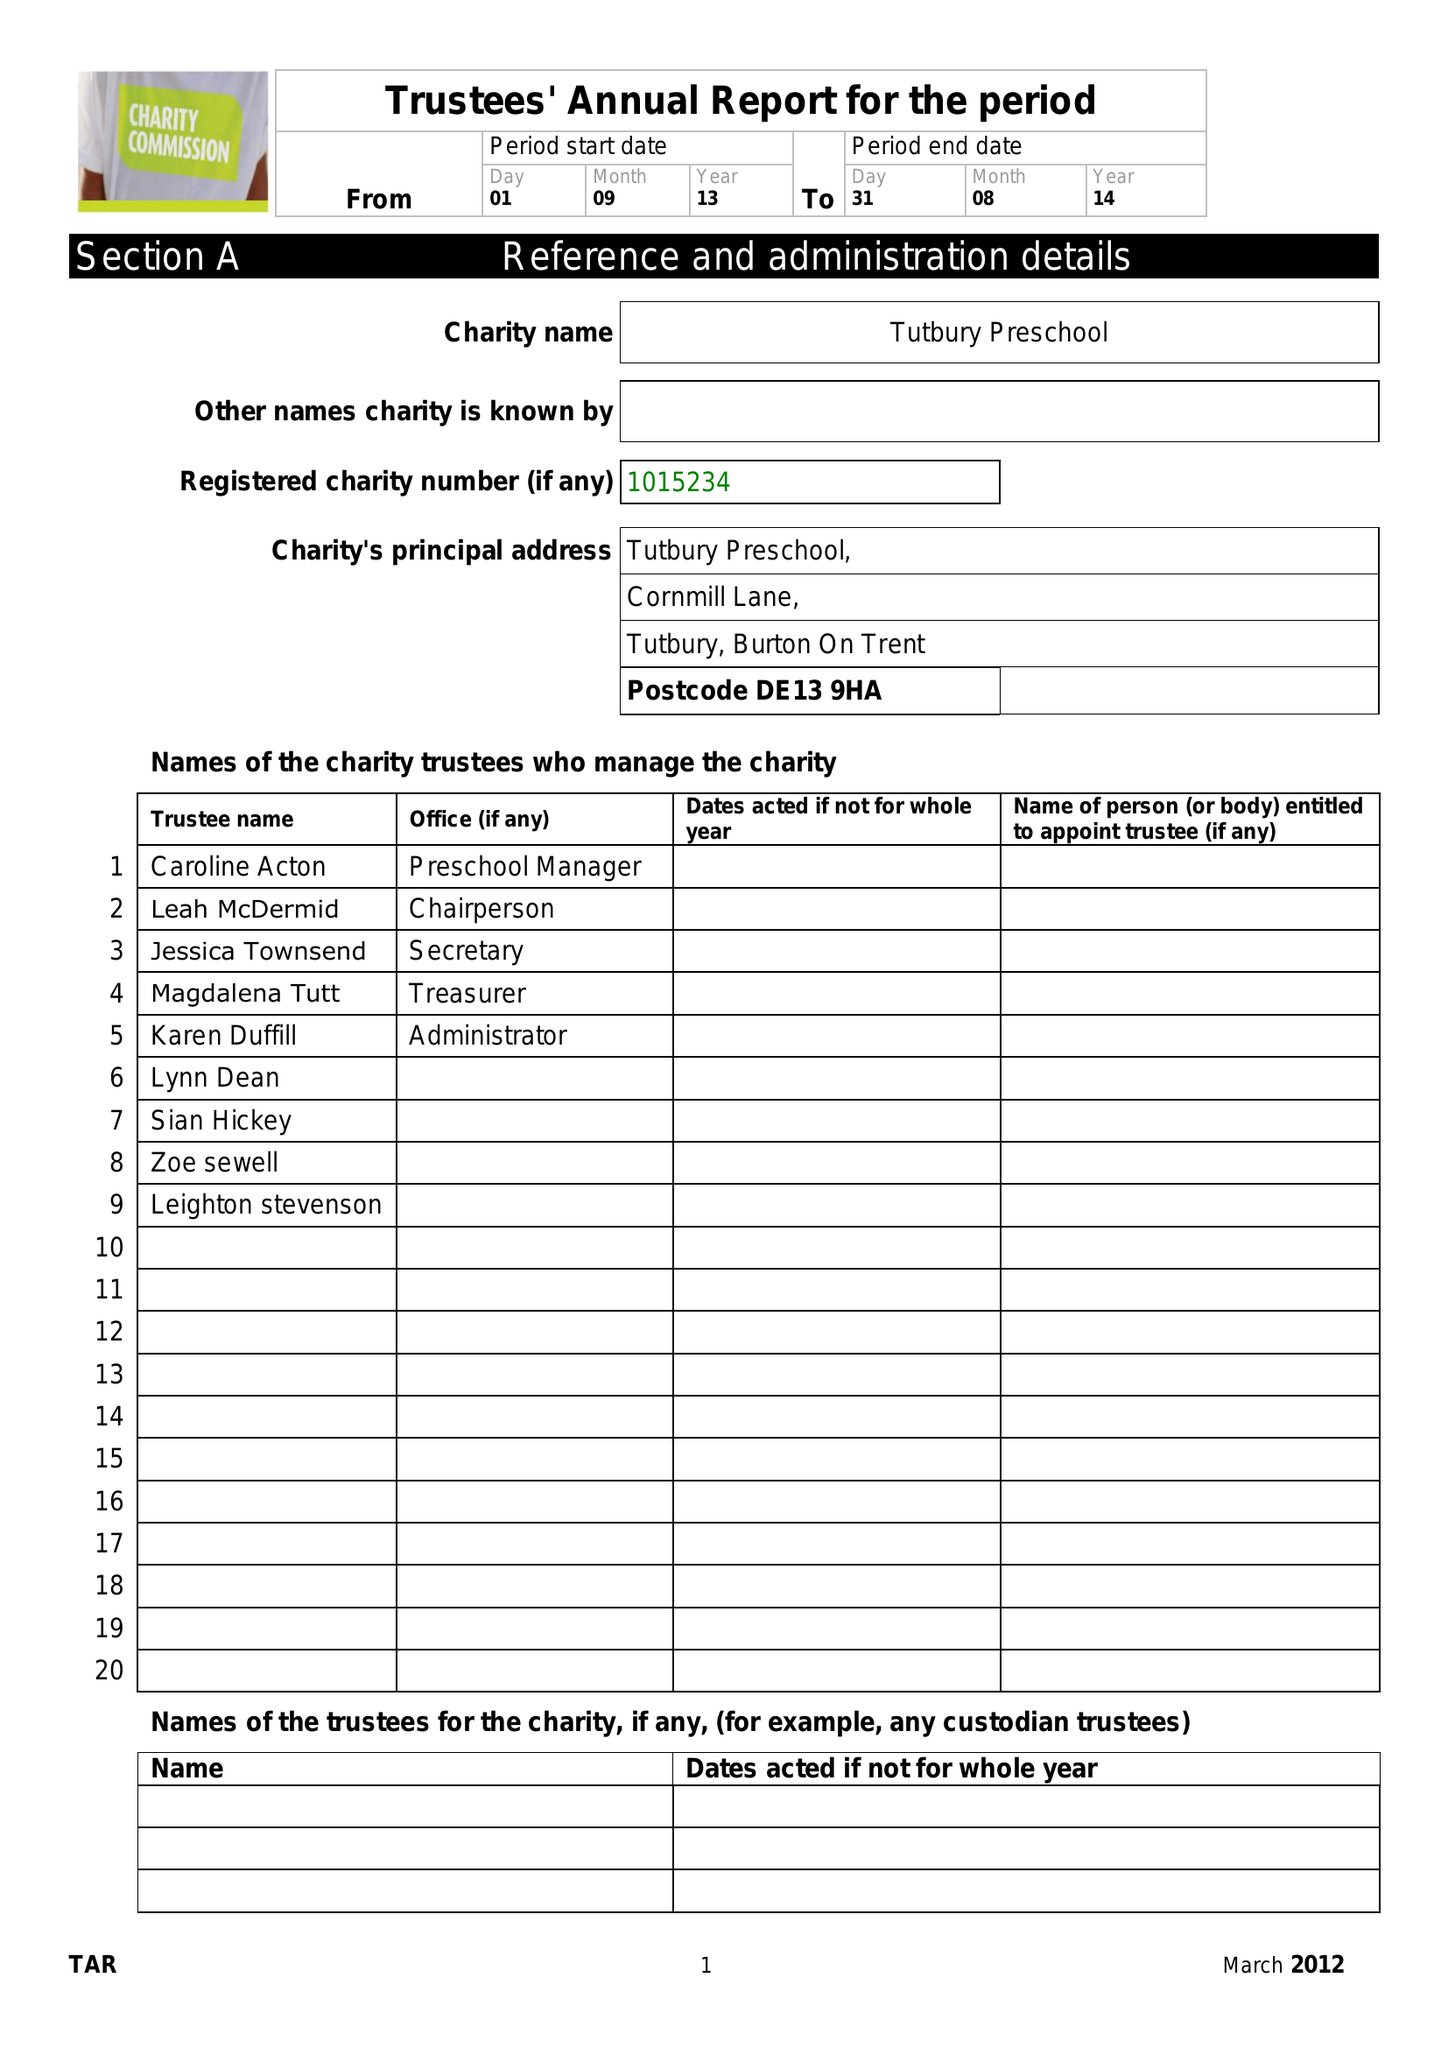What is the value for the spending_annually_in_british_pounds?
Answer the question using a single word or phrase. 66991.00 